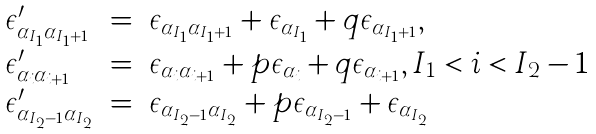Convert formula to latex. <formula><loc_0><loc_0><loc_500><loc_500>\begin{array} { l c l } \epsilon ^ { \prime } _ { \alpha _ { I _ { 1 } } \alpha _ { I _ { 1 } + 1 } } & = & \epsilon _ { \alpha _ { I _ { 1 } } \alpha _ { I _ { 1 } + 1 } } + \epsilon _ { \alpha _ { I _ { 1 } } } + q \epsilon _ { \alpha _ { I _ { 1 } + 1 } } , \\ \epsilon ^ { \prime } _ { \alpha _ { i } \alpha _ { i + 1 } } & = & \epsilon _ { \alpha _ { i } \alpha _ { i + 1 } } + p \epsilon _ { \alpha _ { i } } + q \epsilon _ { \alpha _ { i + 1 } } , I _ { 1 } < i < I _ { 2 } - 1 \\ \epsilon ^ { \prime } _ { \alpha _ { I _ { 2 } - 1 } \alpha _ { I _ { 2 } } } & = & \epsilon _ { \alpha _ { I _ { 2 } - 1 } \alpha _ { I _ { 2 } } } + p \epsilon _ { \alpha _ { I _ { 2 } - 1 } } + \epsilon _ { \alpha _ { I _ { 2 } } } \end{array}</formula> 